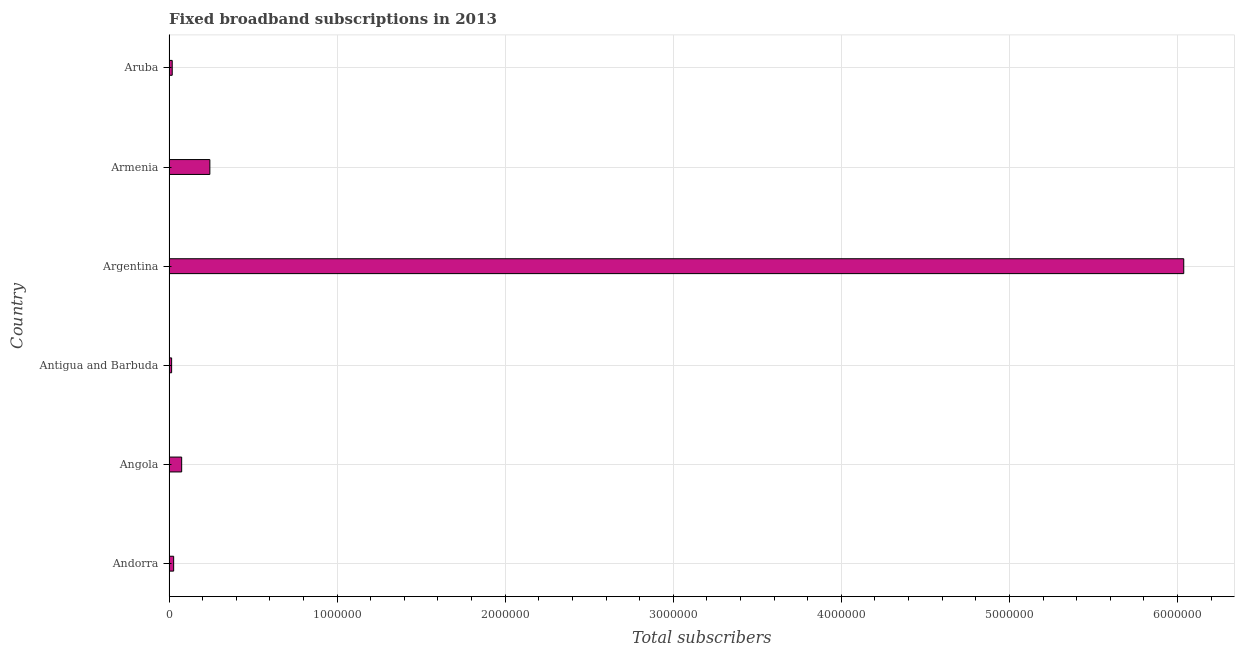Does the graph contain any zero values?
Keep it short and to the point. No. Does the graph contain grids?
Offer a terse response. Yes. What is the title of the graph?
Offer a terse response. Fixed broadband subscriptions in 2013. What is the label or title of the X-axis?
Your answer should be very brief. Total subscribers. What is the total number of fixed broadband subscriptions in Andorra?
Your response must be concise. 2.77e+04. Across all countries, what is the maximum total number of fixed broadband subscriptions?
Your answer should be compact. 6.04e+06. Across all countries, what is the minimum total number of fixed broadband subscriptions?
Keep it short and to the point. 1.56e+04. In which country was the total number of fixed broadband subscriptions maximum?
Offer a very short reply. Argentina. In which country was the total number of fixed broadband subscriptions minimum?
Offer a terse response. Antigua and Barbuda. What is the sum of the total number of fixed broadband subscriptions?
Keep it short and to the point. 6.42e+06. What is the difference between the total number of fixed broadband subscriptions in Andorra and Angola?
Offer a very short reply. -4.76e+04. What is the average total number of fixed broadband subscriptions per country?
Your response must be concise. 1.07e+06. What is the median total number of fixed broadband subscriptions?
Your response must be concise. 5.15e+04. What is the ratio of the total number of fixed broadband subscriptions in Antigua and Barbuda to that in Argentina?
Provide a short and direct response. 0. What is the difference between the highest and the second highest total number of fixed broadband subscriptions?
Make the answer very short. 5.79e+06. What is the difference between the highest and the lowest total number of fixed broadband subscriptions?
Your answer should be compact. 6.02e+06. In how many countries, is the total number of fixed broadband subscriptions greater than the average total number of fixed broadband subscriptions taken over all countries?
Your answer should be compact. 1. Are all the bars in the graph horizontal?
Ensure brevity in your answer.  Yes. How many countries are there in the graph?
Keep it short and to the point. 6. Are the values on the major ticks of X-axis written in scientific E-notation?
Provide a succinct answer. No. What is the Total subscribers in Andorra?
Make the answer very short. 2.77e+04. What is the Total subscribers of Angola?
Keep it short and to the point. 7.54e+04. What is the Total subscribers in Antigua and Barbuda?
Your answer should be compact. 1.56e+04. What is the Total subscribers of Argentina?
Ensure brevity in your answer.  6.04e+06. What is the Total subscribers in Armenia?
Make the answer very short. 2.43e+05. What is the Total subscribers of Aruba?
Your answer should be very brief. 1.92e+04. What is the difference between the Total subscribers in Andorra and Angola?
Your response must be concise. -4.76e+04. What is the difference between the Total subscribers in Andorra and Antigua and Barbuda?
Provide a short and direct response. 1.21e+04. What is the difference between the Total subscribers in Andorra and Argentina?
Provide a short and direct response. -6.01e+06. What is the difference between the Total subscribers in Andorra and Armenia?
Offer a terse response. -2.15e+05. What is the difference between the Total subscribers in Andorra and Aruba?
Your response must be concise. 8534. What is the difference between the Total subscribers in Angola and Antigua and Barbuda?
Offer a very short reply. 5.97e+04. What is the difference between the Total subscribers in Angola and Argentina?
Provide a succinct answer. -5.96e+06. What is the difference between the Total subscribers in Angola and Armenia?
Provide a short and direct response. -1.68e+05. What is the difference between the Total subscribers in Angola and Aruba?
Give a very brief answer. 5.62e+04. What is the difference between the Total subscribers in Antigua and Barbuda and Argentina?
Keep it short and to the point. -6.02e+06. What is the difference between the Total subscribers in Antigua and Barbuda and Armenia?
Your answer should be very brief. -2.27e+05. What is the difference between the Total subscribers in Antigua and Barbuda and Aruba?
Keep it short and to the point. -3553. What is the difference between the Total subscribers in Argentina and Armenia?
Make the answer very short. 5.79e+06. What is the difference between the Total subscribers in Argentina and Aruba?
Make the answer very short. 6.02e+06. What is the difference between the Total subscribers in Armenia and Aruba?
Offer a very short reply. 2.24e+05. What is the ratio of the Total subscribers in Andorra to that in Angola?
Offer a terse response. 0.37. What is the ratio of the Total subscribers in Andorra to that in Antigua and Barbuda?
Make the answer very short. 1.77. What is the ratio of the Total subscribers in Andorra to that in Argentina?
Provide a succinct answer. 0.01. What is the ratio of the Total subscribers in Andorra to that in Armenia?
Offer a terse response. 0.11. What is the ratio of the Total subscribers in Andorra to that in Aruba?
Offer a very short reply. 1.44. What is the ratio of the Total subscribers in Angola to that in Antigua and Barbuda?
Your answer should be very brief. 4.82. What is the ratio of the Total subscribers in Angola to that in Argentina?
Offer a terse response. 0.01. What is the ratio of the Total subscribers in Angola to that in Armenia?
Make the answer very short. 0.31. What is the ratio of the Total subscribers in Angola to that in Aruba?
Your answer should be compact. 3.92. What is the ratio of the Total subscribers in Antigua and Barbuda to that in Argentina?
Provide a succinct answer. 0. What is the ratio of the Total subscribers in Antigua and Barbuda to that in Armenia?
Ensure brevity in your answer.  0.06. What is the ratio of the Total subscribers in Antigua and Barbuda to that in Aruba?
Ensure brevity in your answer.  0.81. What is the ratio of the Total subscribers in Argentina to that in Armenia?
Your response must be concise. 24.84. What is the ratio of the Total subscribers in Argentina to that in Aruba?
Make the answer very short. 314.42. What is the ratio of the Total subscribers in Armenia to that in Aruba?
Your response must be concise. 12.66. 